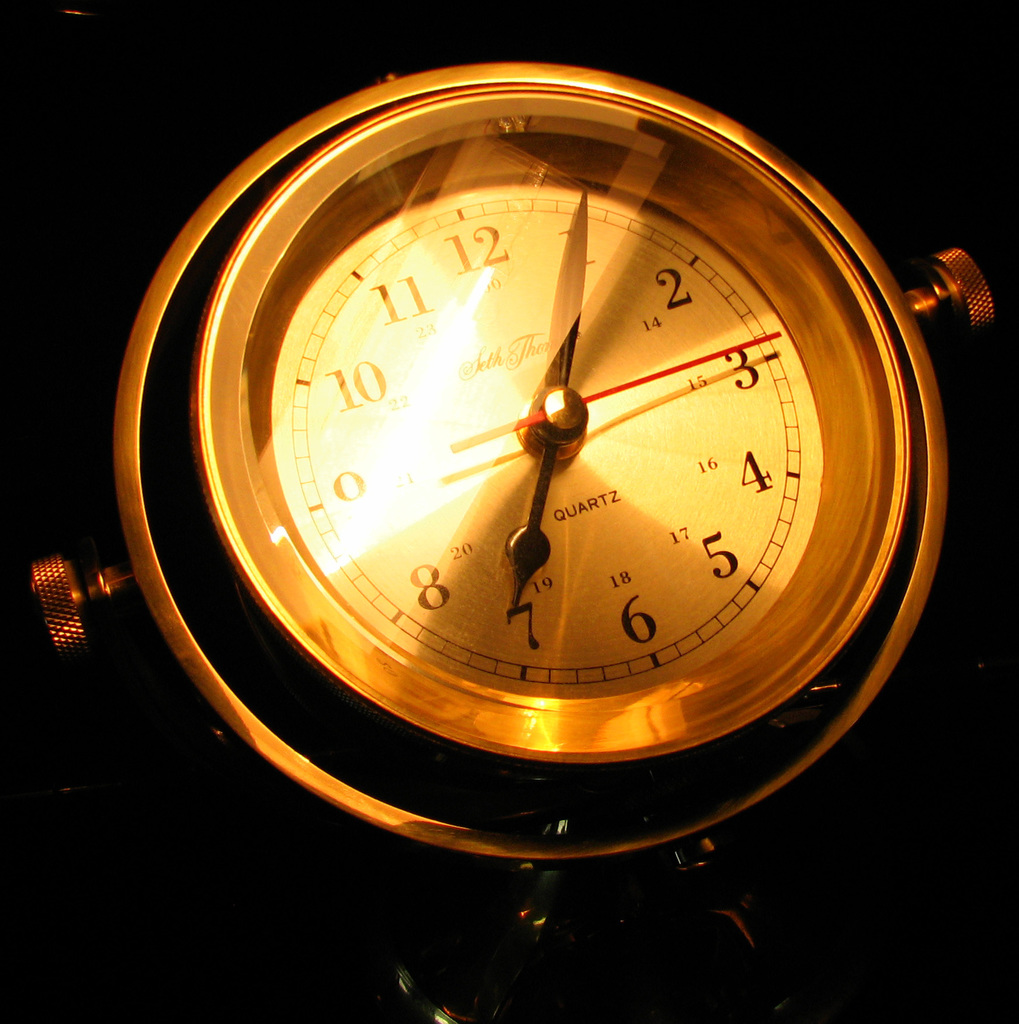Provide a one-sentence caption for the provided image.
Reference OCR token: 11, 2, 10, 4, QUARTZ, 5, 8, 6 The clock shown in the image has a quartz movement. 